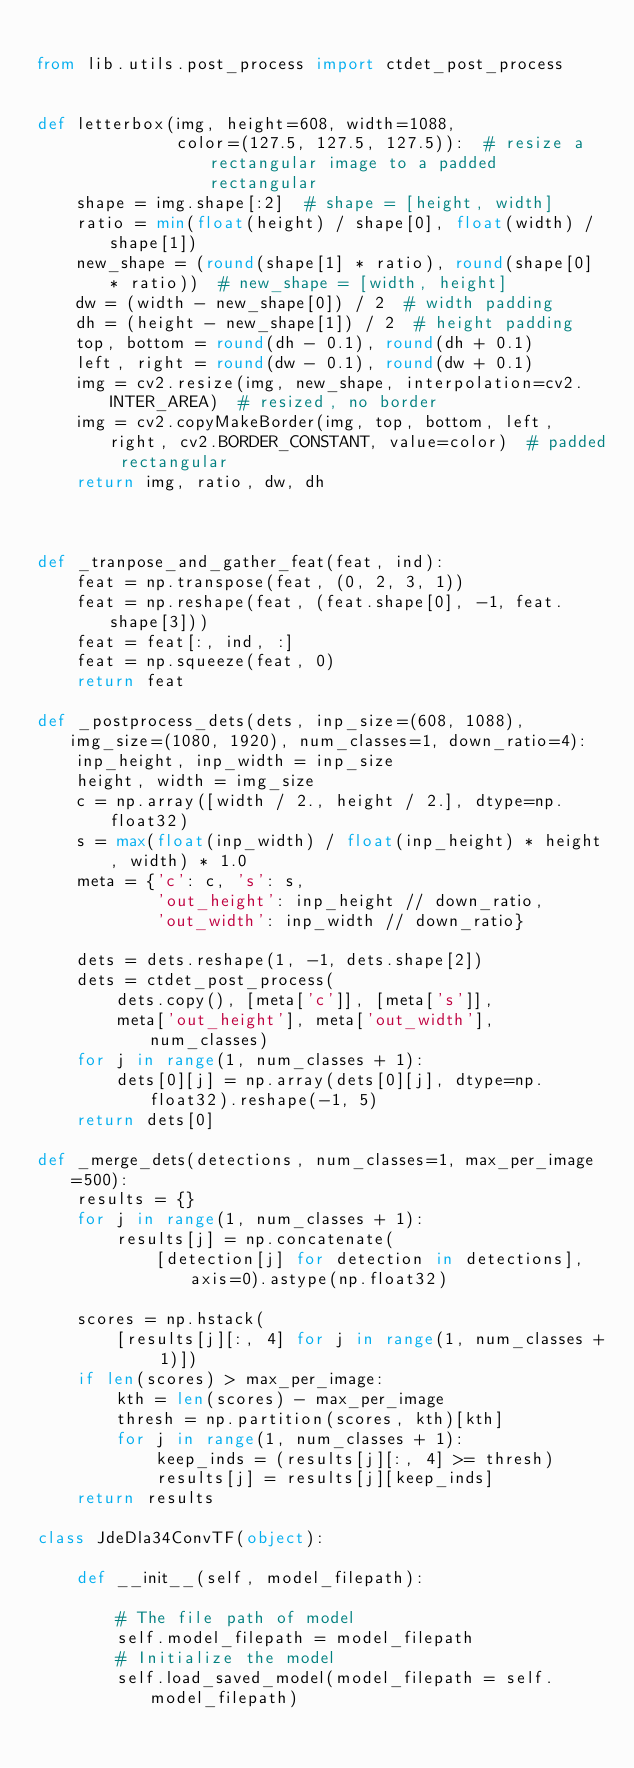<code> <loc_0><loc_0><loc_500><loc_500><_Python_>
from lib.utils.post_process import ctdet_post_process


def letterbox(img, height=608, width=1088,
              color=(127.5, 127.5, 127.5)):  # resize a rectangular image to a padded rectangular
    shape = img.shape[:2]  # shape = [height, width]
    ratio = min(float(height) / shape[0], float(width) / shape[1])
    new_shape = (round(shape[1] * ratio), round(shape[0] * ratio))  # new_shape = [width, height]
    dw = (width - new_shape[0]) / 2  # width padding
    dh = (height - new_shape[1]) / 2  # height padding
    top, bottom = round(dh - 0.1), round(dh + 0.1)
    left, right = round(dw - 0.1), round(dw + 0.1)
    img = cv2.resize(img, new_shape, interpolation=cv2.INTER_AREA)  # resized, no border
    img = cv2.copyMakeBorder(img, top, bottom, left, right, cv2.BORDER_CONSTANT, value=color)  # padded rectangular
    return img, ratio, dw, dh



def _tranpose_and_gather_feat(feat, ind):
    feat = np.transpose(feat, (0, 2, 3, 1))
    feat = np.reshape(feat, (feat.shape[0], -1, feat.shape[3]))
    feat = feat[:, ind, :]
    feat = np.squeeze(feat, 0)
    return feat

def _postprocess_dets(dets, inp_size=(608, 1088), img_size=(1080, 1920), num_classes=1, down_ratio=4):
    inp_height, inp_width = inp_size
    height, width = img_size
    c = np.array([width / 2., height / 2.], dtype=np.float32)
    s = max(float(inp_width) / float(inp_height) * height, width) * 1.0
    meta = {'c': c, 's': s,
            'out_height': inp_height // down_ratio,
            'out_width': inp_width // down_ratio}

    dets = dets.reshape(1, -1, dets.shape[2])
    dets = ctdet_post_process(
        dets.copy(), [meta['c']], [meta['s']],
        meta['out_height'], meta['out_width'], num_classes)
    for j in range(1, num_classes + 1):
        dets[0][j] = np.array(dets[0][j], dtype=np.float32).reshape(-1, 5)
    return dets[0]

def _merge_dets(detections, num_classes=1, max_per_image=500):
    results = {}
    for j in range(1, num_classes + 1):
        results[j] = np.concatenate(
            [detection[j] for detection in detections], axis=0).astype(np.float32)

    scores = np.hstack(
        [results[j][:, 4] for j in range(1, num_classes + 1)])
    if len(scores) > max_per_image:
        kth = len(scores) - max_per_image
        thresh = np.partition(scores, kth)[kth]
        for j in range(1, num_classes + 1):
            keep_inds = (results[j][:, 4] >= thresh)
            results[j] = results[j][keep_inds]
    return results

class JdeDla34ConvTF(object):

    def __init__(self, model_filepath):

        # The file path of model
        self.model_filepath = model_filepath
        # Initialize the model
        self.load_saved_model(model_filepath = self.model_filepath)</code> 